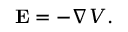Convert formula to latex. <formula><loc_0><loc_0><loc_500><loc_500>E = - \nabla V .</formula> 